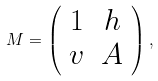Convert formula to latex. <formula><loc_0><loc_0><loc_500><loc_500>M = \left ( \begin{array} { c c } 1 & h \\ v & A \end{array} \right ) ,</formula> 